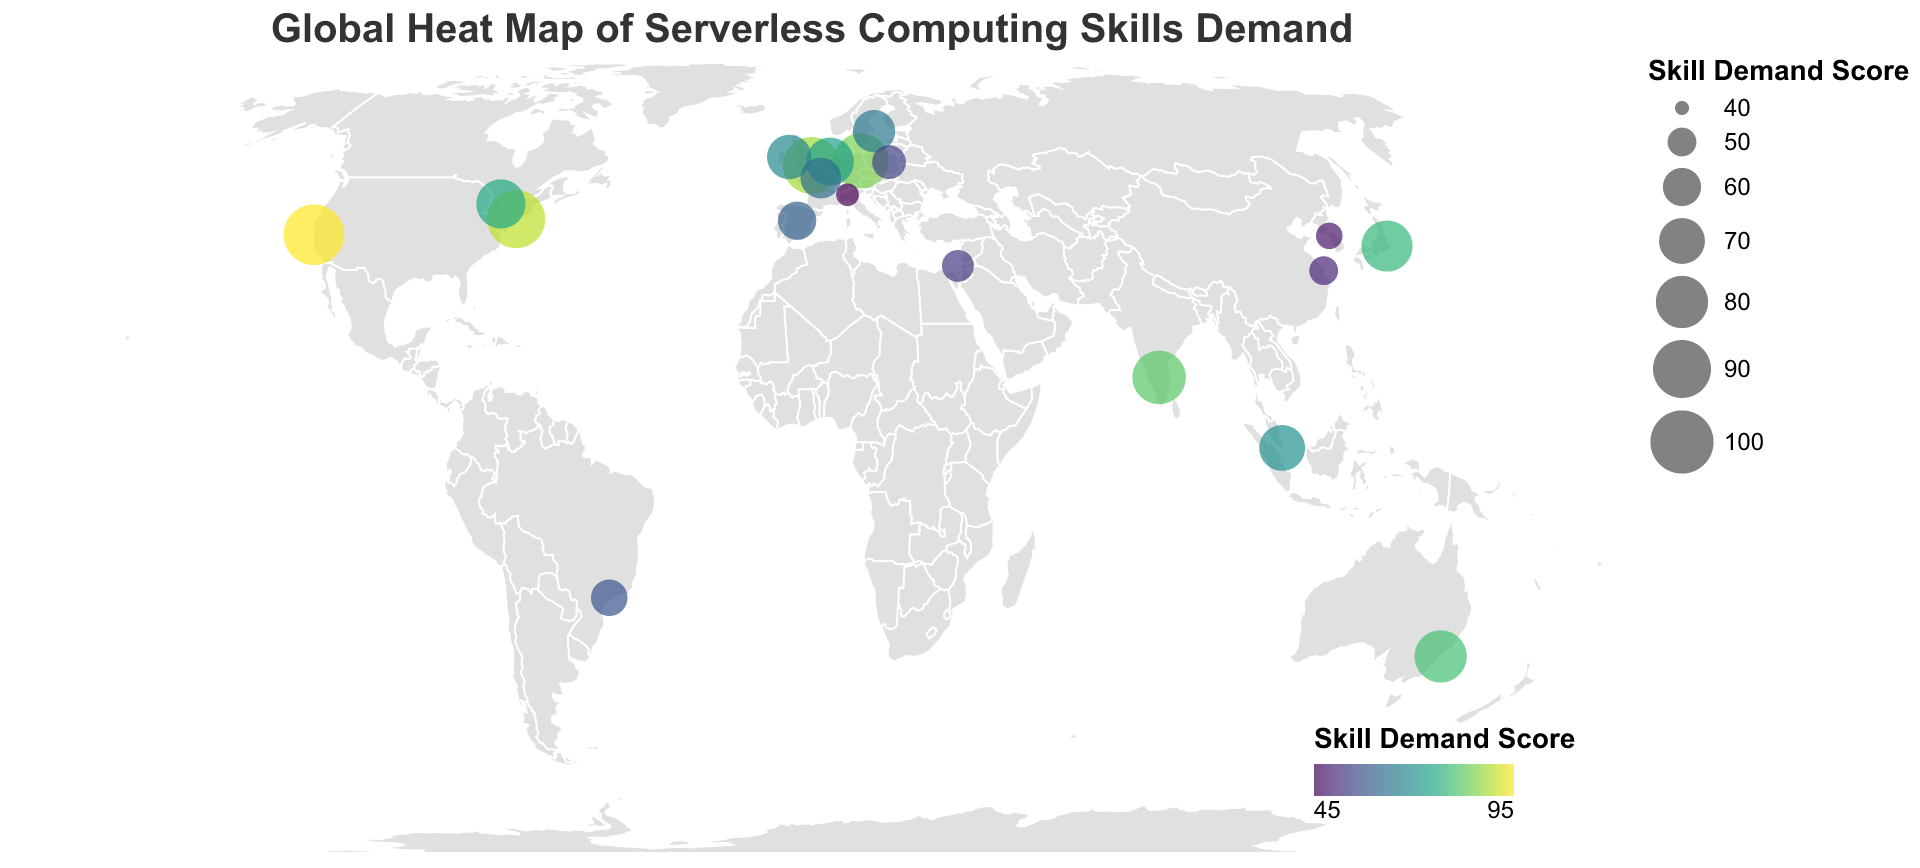What is the title of the figure? The title of the figure is located at the top and it gives a general description of what the figure is about.
Answer: Global Heat Map of Serverless Computing Skills Demand How many regions are included in the United States on the map? By observing the plotted points, we can see that there are two regions in the United States, as represented by two distinct circles on the West Coast and East Coast.
Answer: Two Which region has the highest skill demand score? By examining the sizes and colors of the circles on the map, the largest and darkest circle indicates the highest score. This is located on the West Coast of the United States.
Answer: West Coast, United States What is the skill demand score in Milan, Italy? By identifying the circle on Milan, Italy and referencing its tooltip or color and size compared to the legend, we find the skill demand score.
Answer: 45 What is the difference in skill demand score between Bangalore, India and Sydney, Australia? The skill demand score for Bangalore, India is 82 and for Sydney, Australia is 80. The difference between these two scores is calculated as 82 - 80 = 2.
Answer: 2 Which region has a higher skill demand score: Berlin, Germany, or Amsterdam, Netherlands? Comparing the two regions based on the respective sizes and colors of their circles, Berlin in Germany has a skill demand score of 85 while Amsterdam in the Netherlands has a score of 73. 85 is greater than 73.
Answer: Berlin, Germany What is the median skill demand score of all regions shown on the map? To find the median, we need to list all scores in ascending order and choose the middle value. If the number of values is even, the median is the average of the two central numbers. The sorted scores are: 45, 48, 50, 53, 55, 58, 60, 63, 65, 68, 70, 73, 75, 78, 80, 82, 85, 88, 90, 95. The median is the 10th and 11th values: (68 + 70) / 2 = 69.
Answer: 69 Which continent has the most regions with skill demand scores above 80? We need to count the number of regions with scores above 80 for each continent. North America: 2 (West Coast, East Coast), Europe: 1 (London), Asia: 1 (Bangalore), Australia: 1 (Sydney). North America has the most regions with scores above 80.
Answer: North America What is the average skill demand score for the specified regions in Asia? Identify the regions in Asia and sum their skill demand scores, then divide by the number of regions. The scores are: Bangalore (82), Tokyo (78), Singapore (70), Shanghai (50), Seoul (48), and Tel Aviv (53). Sum: 82 + 78 + 70 + 50 + 48 + 53 = 381. Number of regions: 6. Average: 381 / 6 = 63.5.
Answer: 63.5 Which region has the lowest skill demand score? By inspecting the sizes and colors of the circles, the smallest and lightest circle indicates the lowest score. This is located in Milan, Italy.
Answer: Milan, Italy 